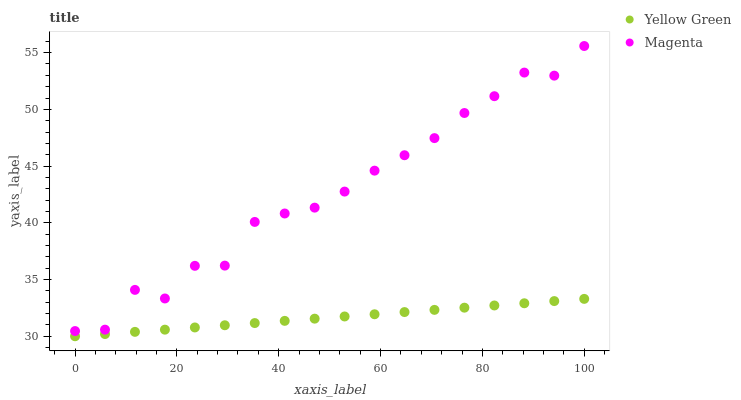Does Yellow Green have the minimum area under the curve?
Answer yes or no. Yes. Does Magenta have the maximum area under the curve?
Answer yes or no. Yes. Does Yellow Green have the maximum area under the curve?
Answer yes or no. No. Is Yellow Green the smoothest?
Answer yes or no. Yes. Is Magenta the roughest?
Answer yes or no. Yes. Is Yellow Green the roughest?
Answer yes or no. No. Does Yellow Green have the lowest value?
Answer yes or no. Yes. Does Magenta have the highest value?
Answer yes or no. Yes. Does Yellow Green have the highest value?
Answer yes or no. No. Is Yellow Green less than Magenta?
Answer yes or no. Yes. Is Magenta greater than Yellow Green?
Answer yes or no. Yes. Does Yellow Green intersect Magenta?
Answer yes or no. No. 